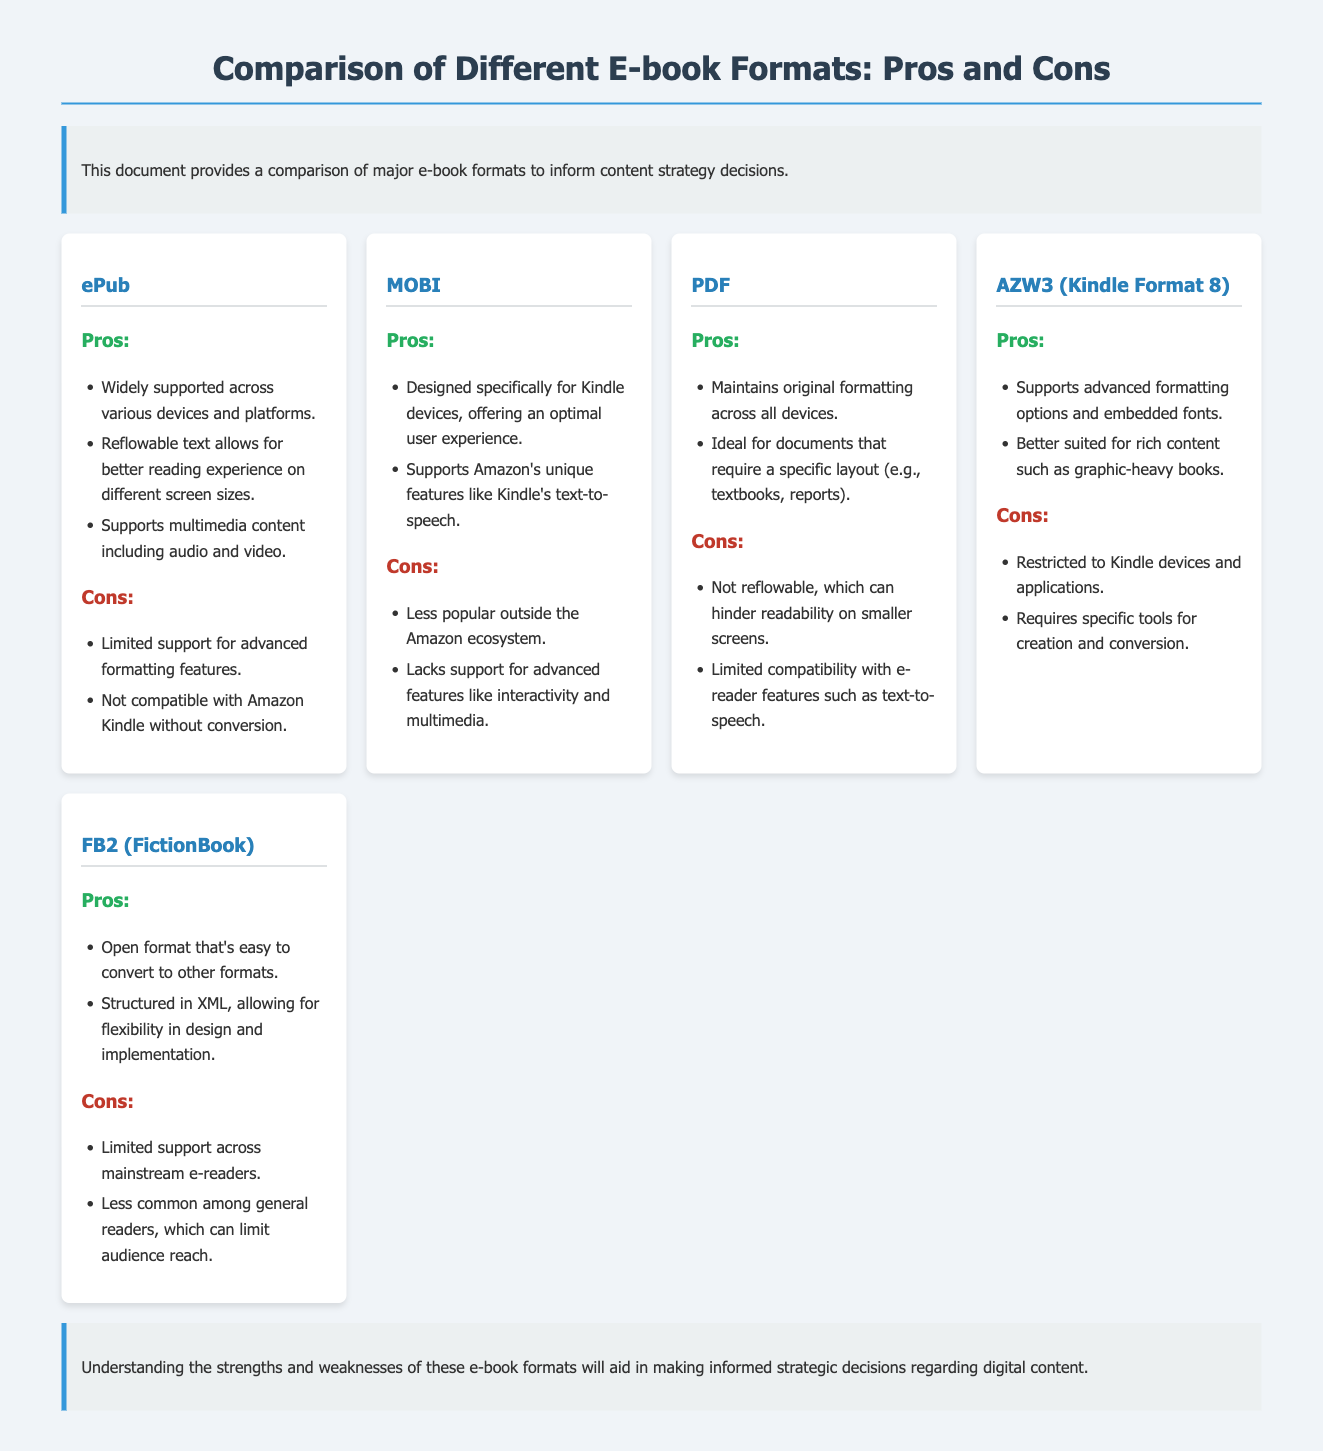What are the three pros of the ePub format? The three pros of the ePub format are: widely supported across various devices and platforms, reflowable text allows for better reading experience on different screen sizes, and supports multimedia content including audio and video.
Answer: Widely supported, reflowable text, supports multimedia What is a major con of the MOBI format? The document states that a major con of the MOBI format is that it lacks support for advanced features like interactivity and multimedia.
Answer: Lacks support for advanced features Which e-book format is specifically designed for Kindle devices? The e-book format that is specifically designed for Kindle devices is MOBI.
Answer: MOBI How many pros are listed for the PDF format? The document mentions two pros for the PDF format: maintains original formatting across all devices and ideal for documents that require a specific layout.
Answer: Two What does FB2 stand for? FB2 stands for FictionBook.
Answer: FictionBook Which format is noted for having limited support across mainstream e-readers? The format noted for having limited support across mainstream e-readers is FB2.
Answer: FB2 What is the primary advantage of the AZW3 format? The primary advantage of the AZW3 format is that it supports advanced formatting options and embedded fonts.
Answer: Supports advanced formatting options What is emphasized in the conclusion of the document? The conclusion emphasizes understanding the strengths and weaknesses of various e-book formats to aid in making informed strategic decisions regarding digital content.
Answer: Understanding strengths and weaknesses Which format is open and easy to convert? The format that is open and easy to convert is FB2.
Answer: FB2 